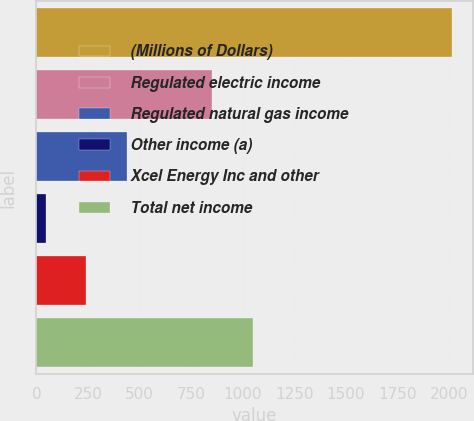Convert chart to OTSL. <chart><loc_0><loc_0><loc_500><loc_500><bar_chart><fcel>(Millions of Dollars)<fcel>Regulated electric income<fcel>Regulated natural gas income<fcel>Other income (a)<fcel>Xcel Energy Inc and other<fcel>Total net income<nl><fcel>2013<fcel>850.7<fcel>438.28<fcel>44.6<fcel>241.44<fcel>1047.54<nl></chart> 